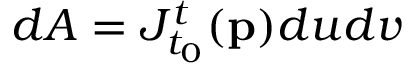<formula> <loc_0><loc_0><loc_500><loc_500>d A = J _ { t _ { 0 } } ^ { t } ( p ) d u d v</formula> 